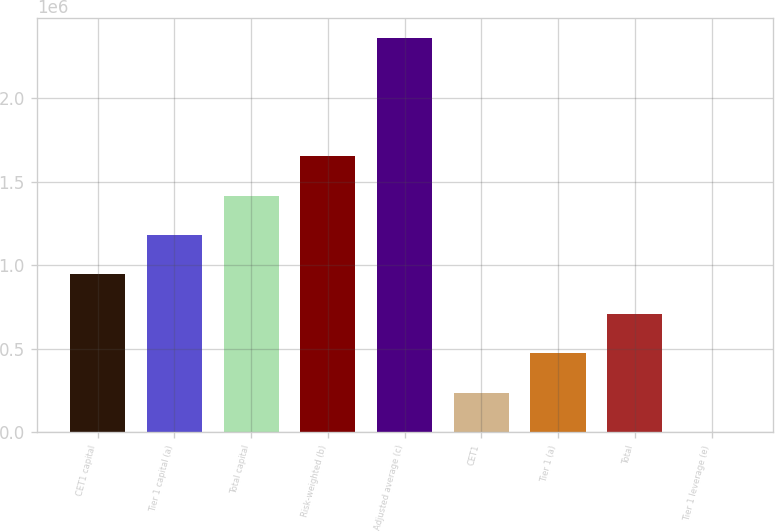Convert chart. <chart><loc_0><loc_0><loc_500><loc_500><bar_chart><fcel>CET1 capital<fcel>Tier 1 capital (a)<fcel>Total capital<fcel>Risk-weighted (b)<fcel>Adjusted average (c)<fcel>CET1<fcel>Tier 1 (a)<fcel>Total<fcel>Tier 1 leverage (e)<nl><fcel>944476<fcel>1.18059e+06<fcel>1.41671e+06<fcel>1.65283e+06<fcel>2.36118e+06<fcel>236125<fcel>472242<fcel>708359<fcel>8.5<nl></chart> 